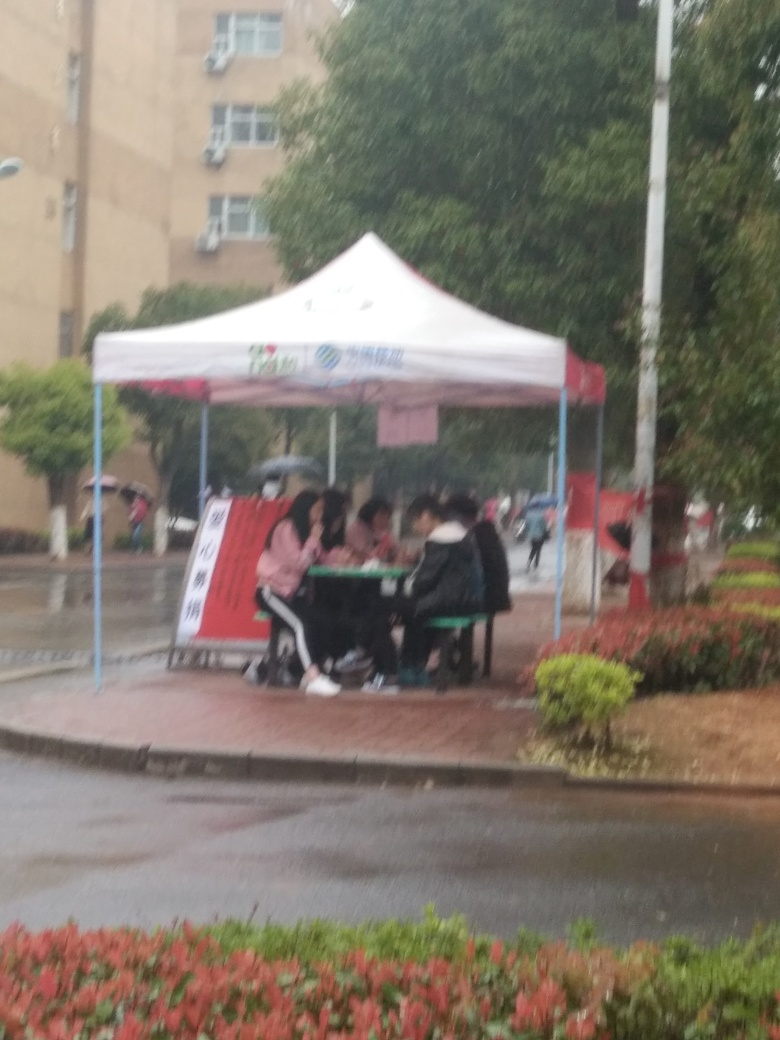Are the outlines of the subjects visible? The outlines of the subjects are somewhat visible; however, due to the blurriness and conditions of the image, the details are not very clear. It appears to be a group of individuals seated under a canopy, possibly due to rain, as the ground looks wet and the sky overcast. 